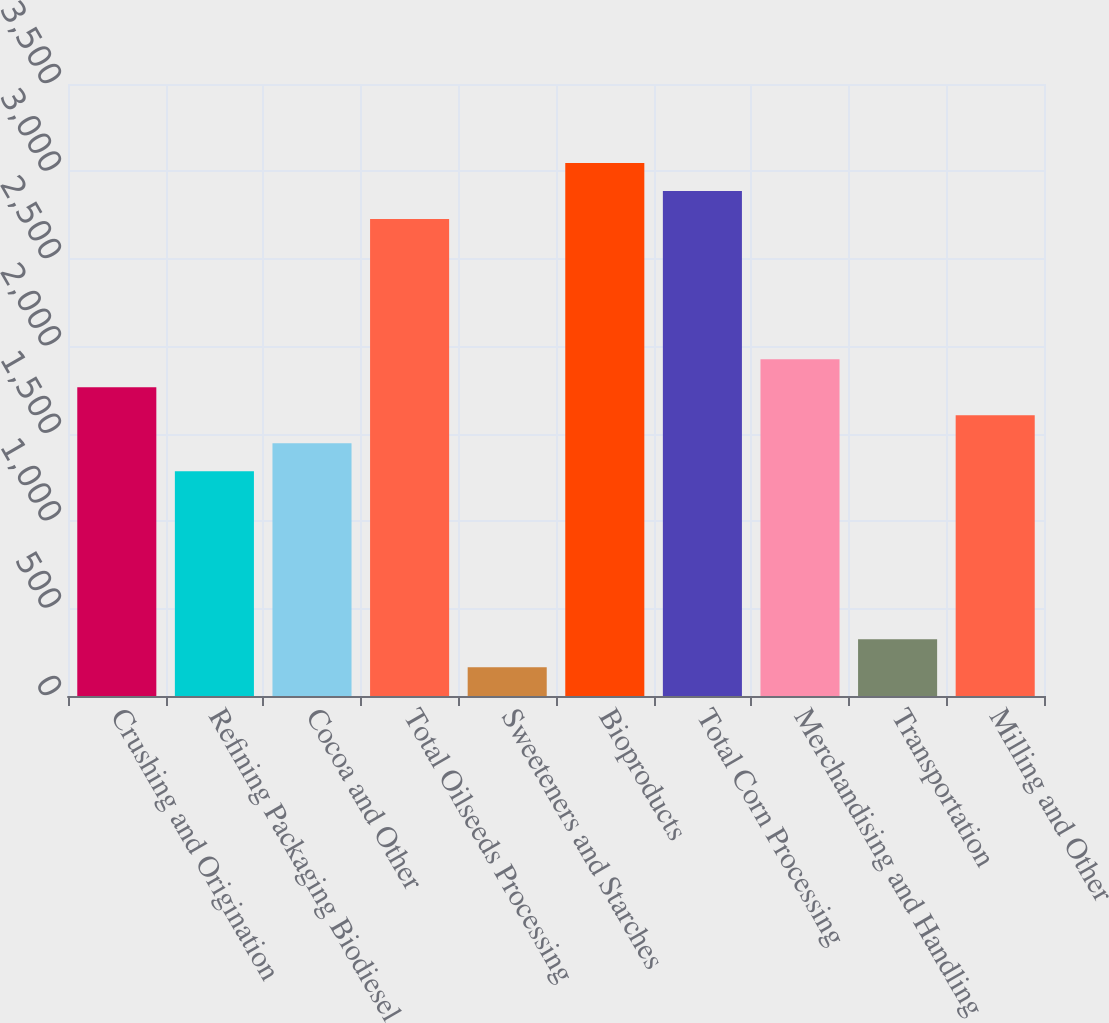Convert chart to OTSL. <chart><loc_0><loc_0><loc_500><loc_500><bar_chart><fcel>Crushing and Origination<fcel>Refining Packaging Biodiesel<fcel>Cocoa and Other<fcel>Total Oilseeds Processing<fcel>Sweeteners and Starches<fcel>Bioproducts<fcel>Total Corn Processing<fcel>Merchandising and Handling<fcel>Transportation<fcel>Milling and Other<nl><fcel>1766.2<fcel>1285.6<fcel>1445.8<fcel>2727.4<fcel>164.2<fcel>3047.8<fcel>2887.6<fcel>1926.4<fcel>324.4<fcel>1606<nl></chart> 